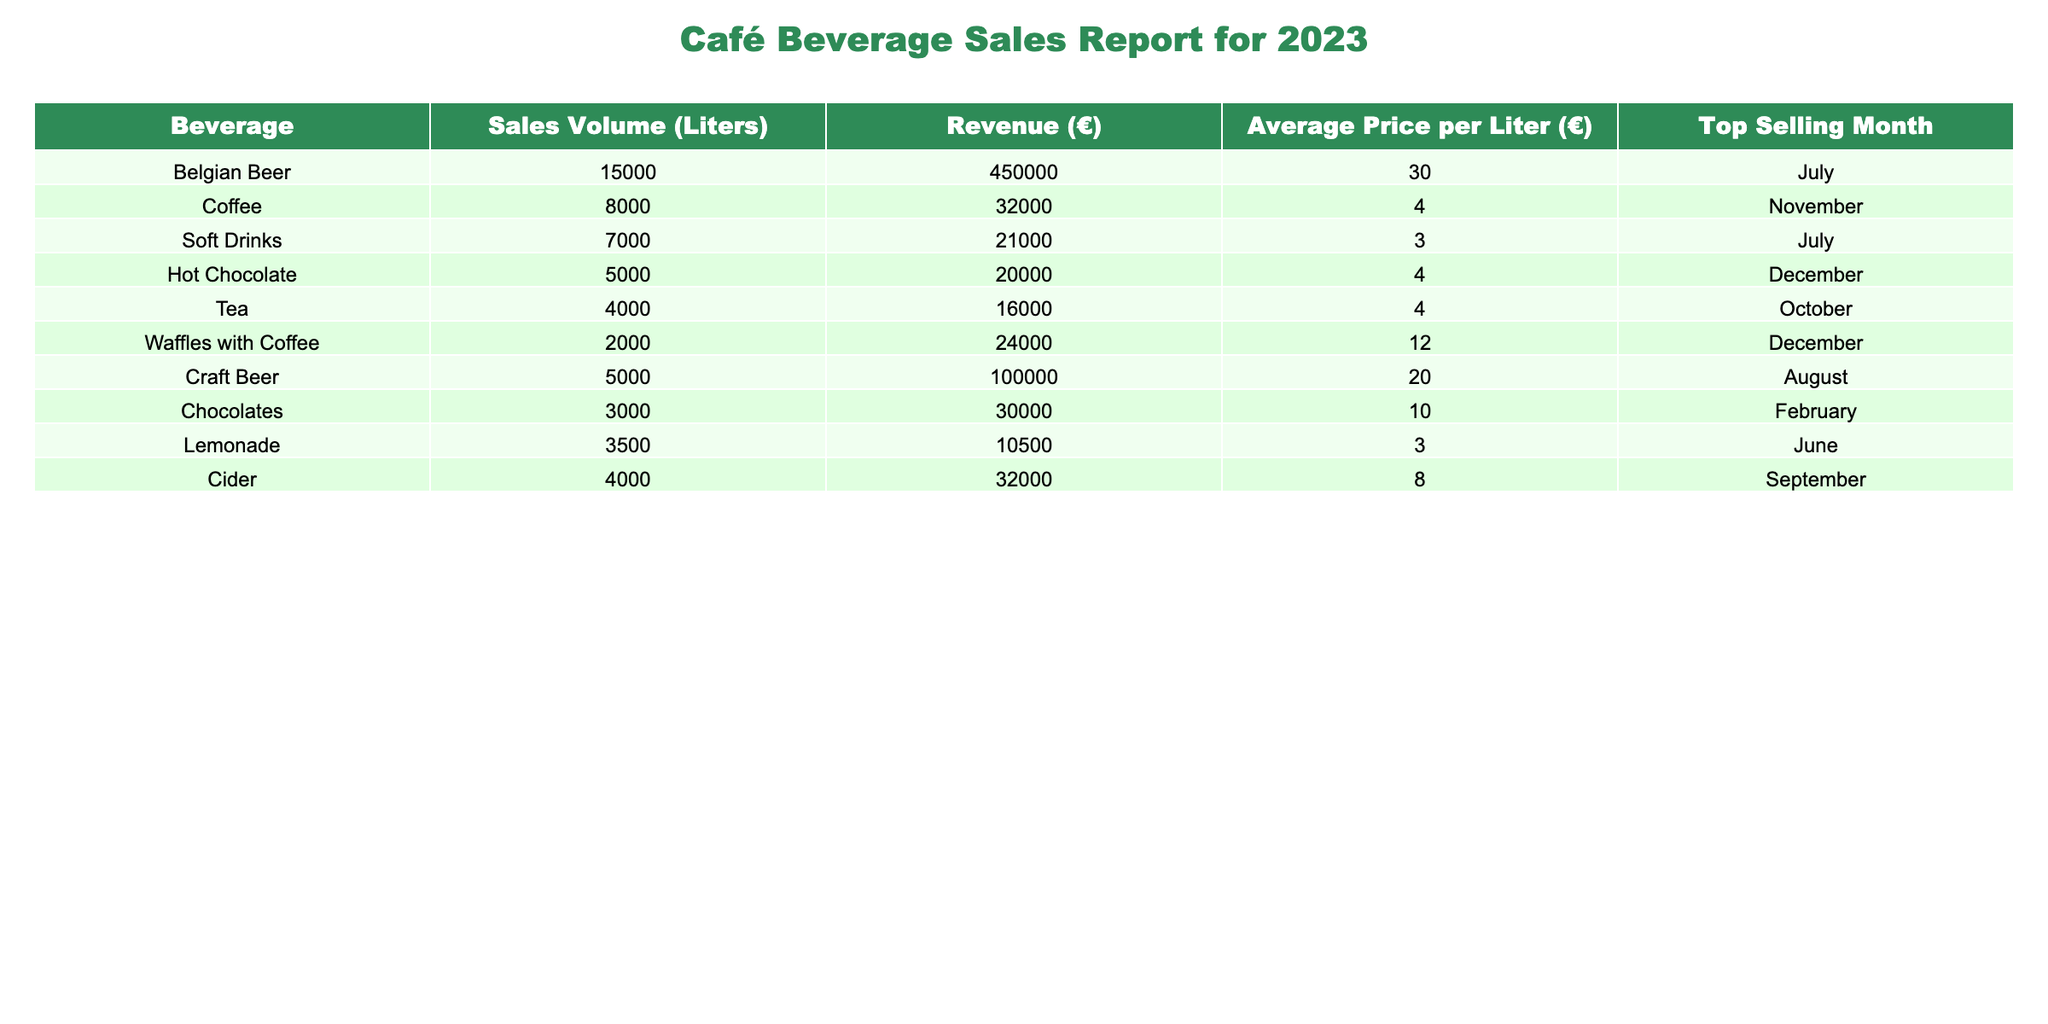What is the total revenue generated from Belgian Beer sales? The revenue for Belgian Beer is listed under the Revenue (€) column, which indicates it's €450,000.
Answer: €450,000 Which beverage had the highest sales volume? The highest sales volume is shown for Belgian Beer with 15,000 liters.
Answer: Belgian Beer What is the average price per liter of Tea? The Average Price per Liter (€) for Tea is listed as €4.
Answer: €4 Which month was the top selling month for Coffee? The table indicates that Coffee's top selling month is November.
Answer: November What is the total sales volume of Soft Drinks and Lemonade combined? The sales volume for Soft Drinks is 7,000 liters and for Lemonade is 3,500 liters. Summing these gives 7,000 + 3,500 = 10,500 liters.
Answer: 10,500 liters Is the average price per liter of Craft Beer greater than that of Belgian Beer? The average price per liter of Craft Beer is €20, while for Belgian Beer it is €30. Since €20 is not greater than €30, the answer is no.
Answer: No Which beverage had the lowest revenue, and what was that revenue? According to the table, Lemonade has the lowest revenue of €10,500.
Answer: Lemonade, €10,500 How much revenue did Hot Chocolate generate compared to Coffee? Hot Chocolate generated €20,000, while Coffee generated €32,000. Subtracting gives €32,000 - €20,000 = €12,000 more for Coffee.
Answer: Coffee generated €12,000 more What is the average revenue of the Top Selling Months for all beverages? The revenues for each beverage from the top selling months are: Belgian Beer (€450,000), Coffee (€32,000), Soft Drinks (€21,000), Hot Chocolate (€20,000), Tea (€16,000), Waffles with Coffee (€24,000), Craft Beer (€100,000), Chocolates (€30,000), Lemonade (€10,500), and Cider (€32,000). The total revenue is €450,000 + €32,000 + €21,000 + €20,000 + €16,000 + €24,000 + €100,000 + €30,000 + €10,500 + €32,000 = €735,500. Dividing by 10 provides an average of €73,550.
Answer: €73,550 Does Hot Chocolate have a higher average price per liter than Soft Drinks? Hot Chocolate's average price is €4 and Soft Drinks is €3. Therefore, Hot Chocolate has a higher average price.
Answer: Yes 